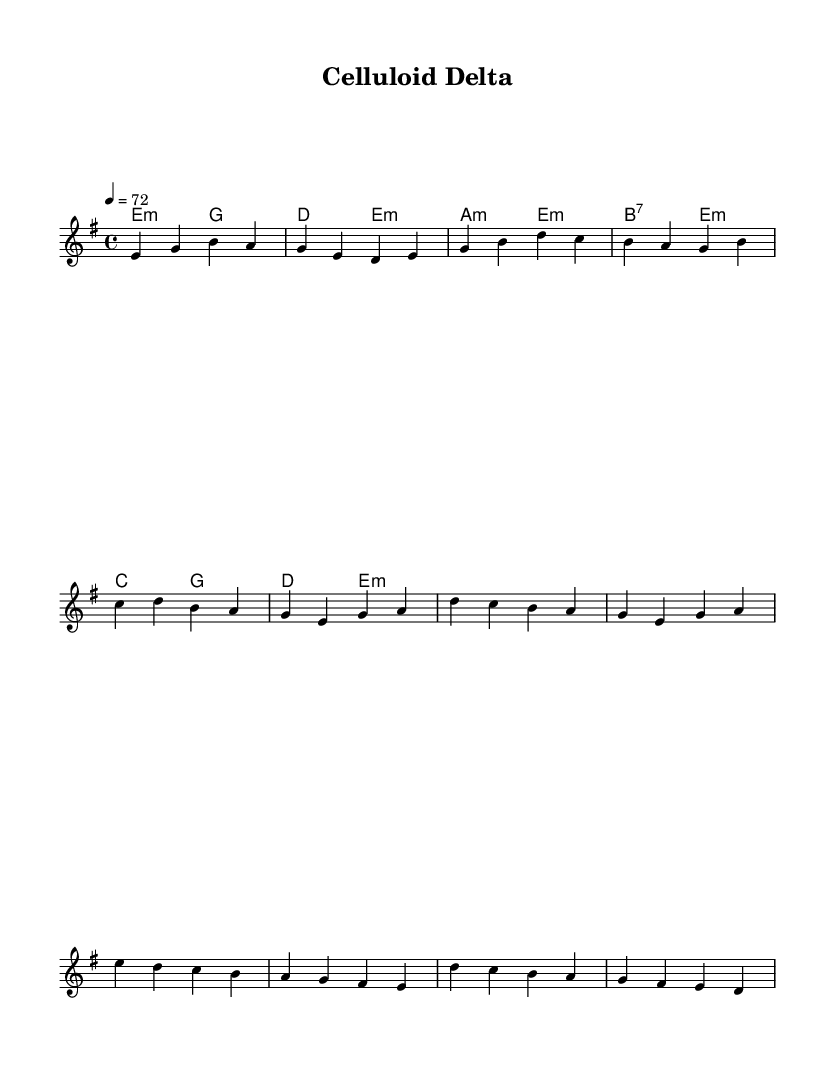What is the key signature of this music? The key signature is E minor, indicated by the presence of one sharp (F#) which is typical for this key.
Answer: E minor What is the time signature of this piece? The time signature is 4/4, which is shown at the beginning of the score. This means there are four beats in each measure, and the quarter note gets one beat.
Answer: 4/4 What is the tempo marking for this score? The tempo marking is provided as a metronome marking of 72 beats per minute, indicating the speed at which this piece should be played.
Answer: 72 How many measures are in the verse section? The verse section consists of four measures, as indicated in the melody part of the score. Counting from the first note to the last in the verse, there are four distinct bars.
Answer: 4 Which chord follows the C chord in the chorus? The C chord is followed by the D chord in the chorus as per the chord progression given in the score. This is part of the standout transition within that section.
Answer: D What type of music does this score represent? This score represents Electric Blues, characterized by its use of blues scales and a narrative structure similar to Delta blues, emphasizing storytelling through music.
Answer: Electric Blues What is the final chord in the bridge section? The final chord in the bridge section is E minor, which concludes this part of the piece and maintains the somber tonal quality associated with the earlier sections.
Answer: E minor 